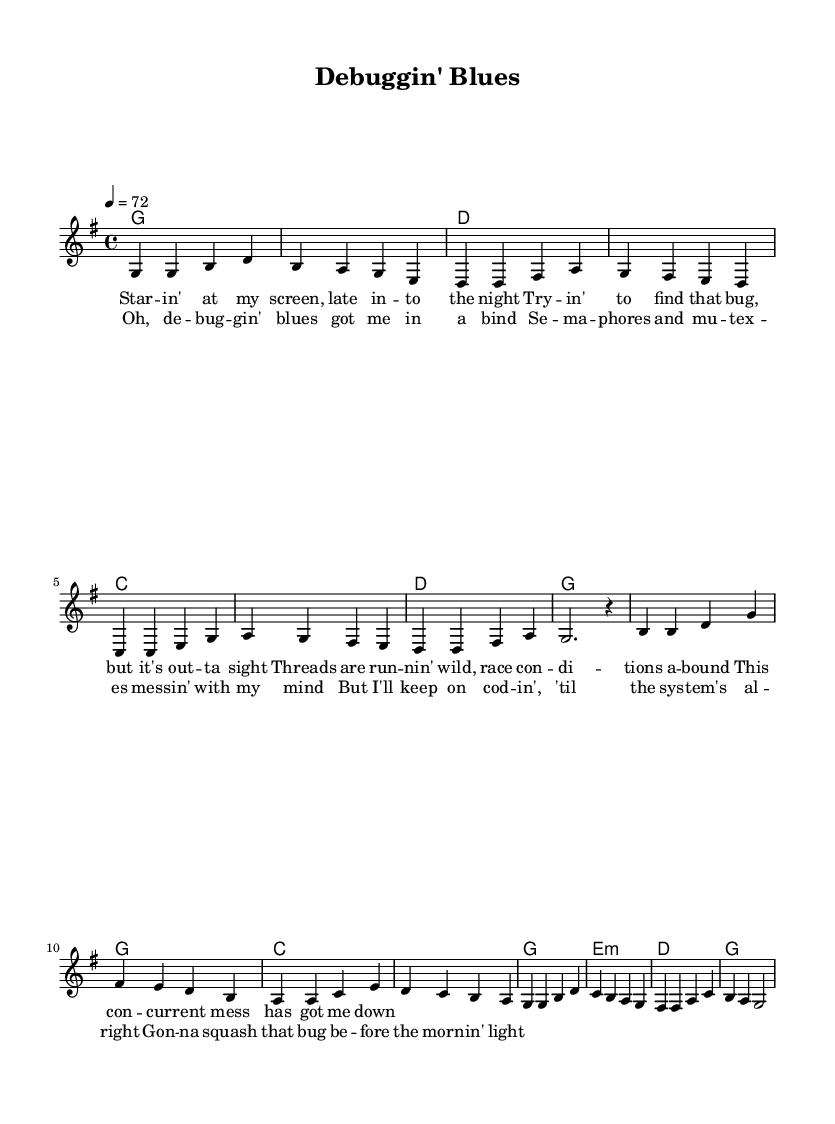What is the key signature of this music? The key signature is G major, which has one sharp (F#). This can be identified by looking at the key signature indicator at the beginning of the score.
Answer: G major What is the time signature of this piece? The time signature is 4/4, which indicates that there are four beats in each measure and the quarter note receives one beat. This is shown right after the key signature in the score.
Answer: 4/4 What is the tempo marking for the piece? The tempo marking is 4 equals 72, indicating that each quarter note should be played at a speed of 72 beats per minute. This information is found at the beginning of the global settings in the score.
Answer: 72 How many measures are in the verse? The verse consists of 8 measures, which can be counted by looking at the melody section and identifying the distinct segments separated by the vertical lines in the sheet music.
Answer: 8 measures What is the primary theme of the lyrics? The primary theme of the lyrics revolves around debugging complex systems, particularly the frustrations of dealing with bugs and threading issues. This can be deduced from the content of both the verse and chorus lyrics.
Answer: Debugging frustrations What chords are used in the chorus? The chords used in the chorus are G, C, and E minor. This can be determined by examining the chord symbols above the melody during the chorus lyrics section, which clearly indicates these chords.
Answer: G, C, E minor What musical style does this piece represent? This piece represents the Country musical style, which is evident from the structure, themes, and the overall ballad form typical of classic country music. The lyrics and melodies support this categorization.
Answer: Country 